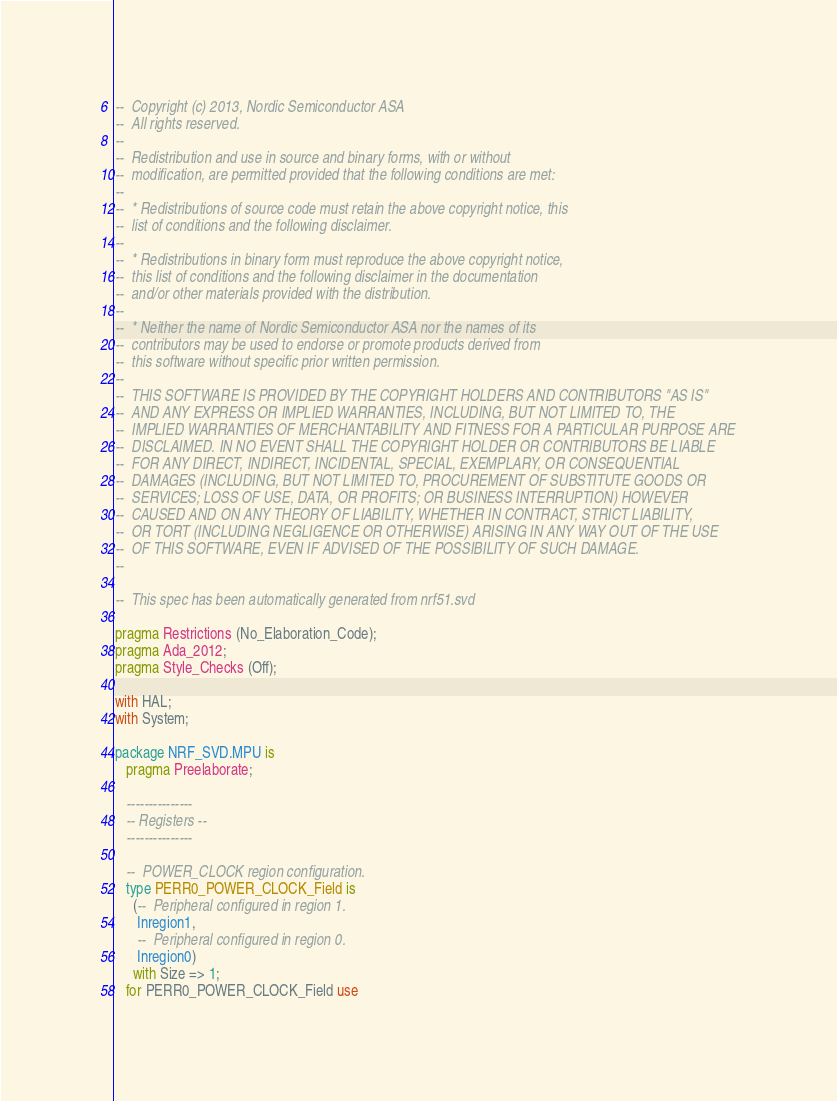<code> <loc_0><loc_0><loc_500><loc_500><_Ada_>--  Copyright (c) 2013, Nordic Semiconductor ASA
--  All rights reserved.
--
--  Redistribution and use in source and binary forms, with or without
--  modification, are permitted provided that the following conditions are met:
--
--  * Redistributions of source code must retain the above copyright notice, this
--  list of conditions and the following disclaimer.
--
--  * Redistributions in binary form must reproduce the above copyright notice,
--  this list of conditions and the following disclaimer in the documentation
--  and/or other materials provided with the distribution.
--
--  * Neither the name of Nordic Semiconductor ASA nor the names of its
--  contributors may be used to endorse or promote products derived from
--  this software without specific prior written permission.
--
--  THIS SOFTWARE IS PROVIDED BY THE COPYRIGHT HOLDERS AND CONTRIBUTORS "AS IS"
--  AND ANY EXPRESS OR IMPLIED WARRANTIES, INCLUDING, BUT NOT LIMITED TO, THE
--  IMPLIED WARRANTIES OF MERCHANTABILITY AND FITNESS FOR A PARTICULAR PURPOSE ARE
--  DISCLAIMED. IN NO EVENT SHALL THE COPYRIGHT HOLDER OR CONTRIBUTORS BE LIABLE
--  FOR ANY DIRECT, INDIRECT, INCIDENTAL, SPECIAL, EXEMPLARY, OR CONSEQUENTIAL
--  DAMAGES (INCLUDING, BUT NOT LIMITED TO, PROCUREMENT OF SUBSTITUTE GOODS OR
--  SERVICES; LOSS OF USE, DATA, OR PROFITS; OR BUSINESS INTERRUPTION) HOWEVER
--  CAUSED AND ON ANY THEORY OF LIABILITY, WHETHER IN CONTRACT, STRICT LIABILITY,
--  OR TORT (INCLUDING NEGLIGENCE OR OTHERWISE) ARISING IN ANY WAY OUT OF THE USE
--  OF THIS SOFTWARE, EVEN IF ADVISED OF THE POSSIBILITY OF SUCH DAMAGE.
--

--  This spec has been automatically generated from nrf51.svd

pragma Restrictions (No_Elaboration_Code);
pragma Ada_2012;
pragma Style_Checks (Off);

with HAL;
with System;

package NRF_SVD.MPU is
   pragma Preelaborate;

   ---------------
   -- Registers --
   ---------------

   --  POWER_CLOCK region configuration.
   type PERR0_POWER_CLOCK_Field is
     (--  Peripheral configured in region 1.
      Inregion1,
      --  Peripheral configured in region 0.
      Inregion0)
     with Size => 1;
   for PERR0_POWER_CLOCK_Field use</code> 